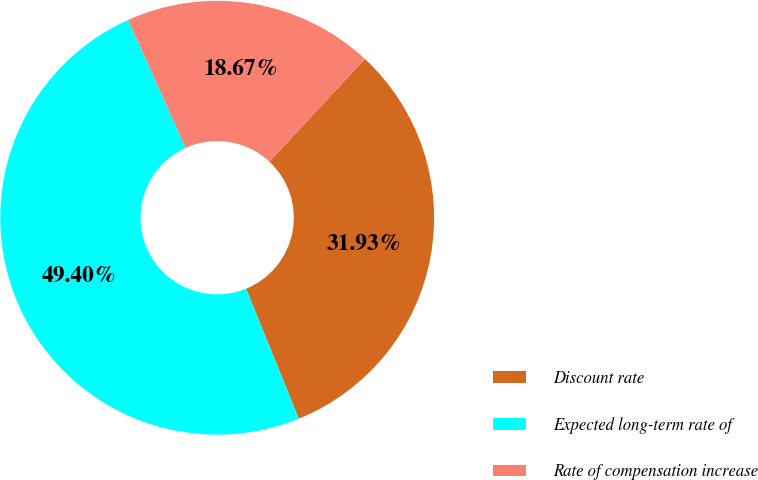Convert chart to OTSL. <chart><loc_0><loc_0><loc_500><loc_500><pie_chart><fcel>Discount rate<fcel>Expected long-term rate of<fcel>Rate of compensation increase<nl><fcel>31.93%<fcel>49.4%<fcel>18.67%<nl></chart> 